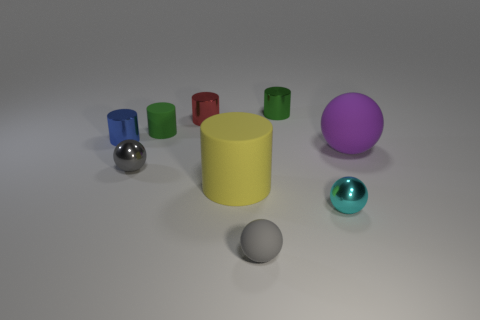Do the large object on the right side of the yellow cylinder and the small rubber thing that is to the left of the small red metal object have the same shape? No, they do not have the same shape. The large object to the right of the yellow cylinder is a sphere, while the small object to the left of the small red metal object appears to be a cube. 